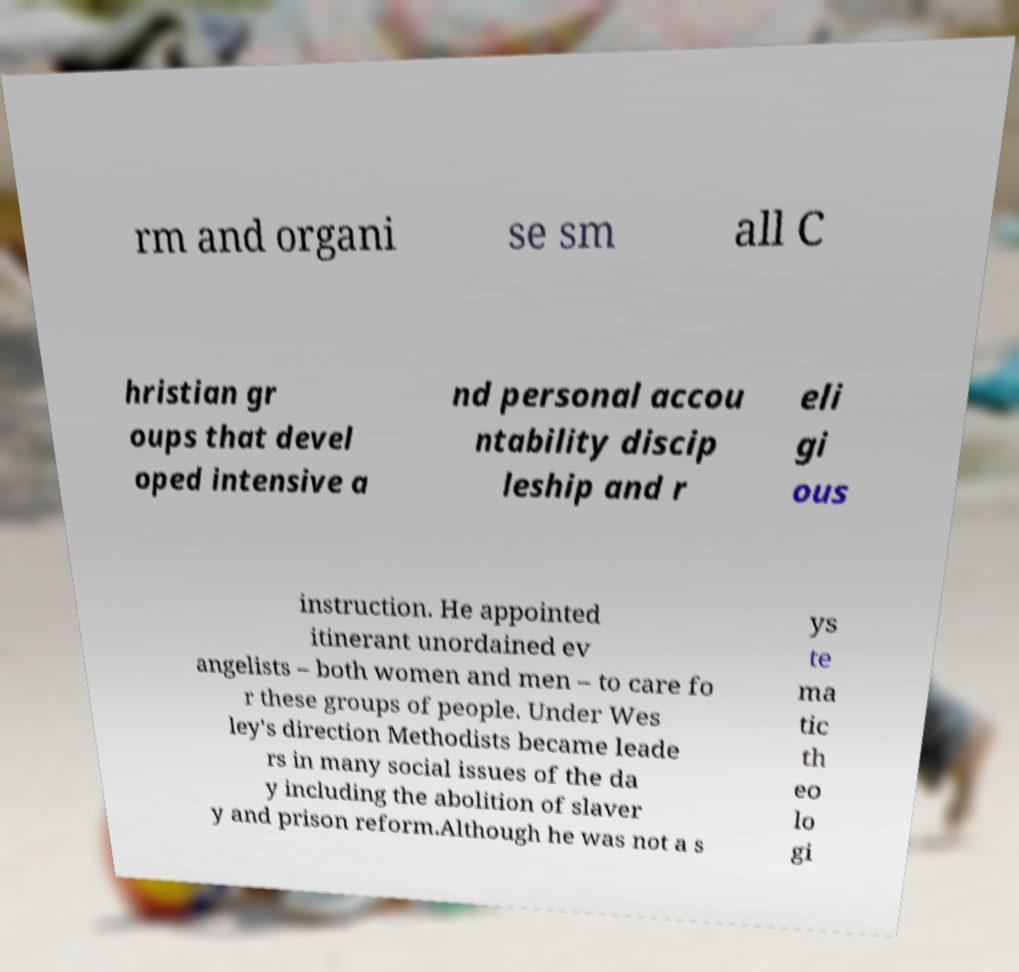For documentation purposes, I need the text within this image transcribed. Could you provide that? rm and organi se sm all C hristian gr oups that devel oped intensive a nd personal accou ntability discip leship and r eli gi ous instruction. He appointed itinerant unordained ev angelists – both women and men – to care fo r these groups of people. Under Wes ley's direction Methodists became leade rs in many social issues of the da y including the abolition of slaver y and prison reform.Although he was not a s ys te ma tic th eo lo gi 